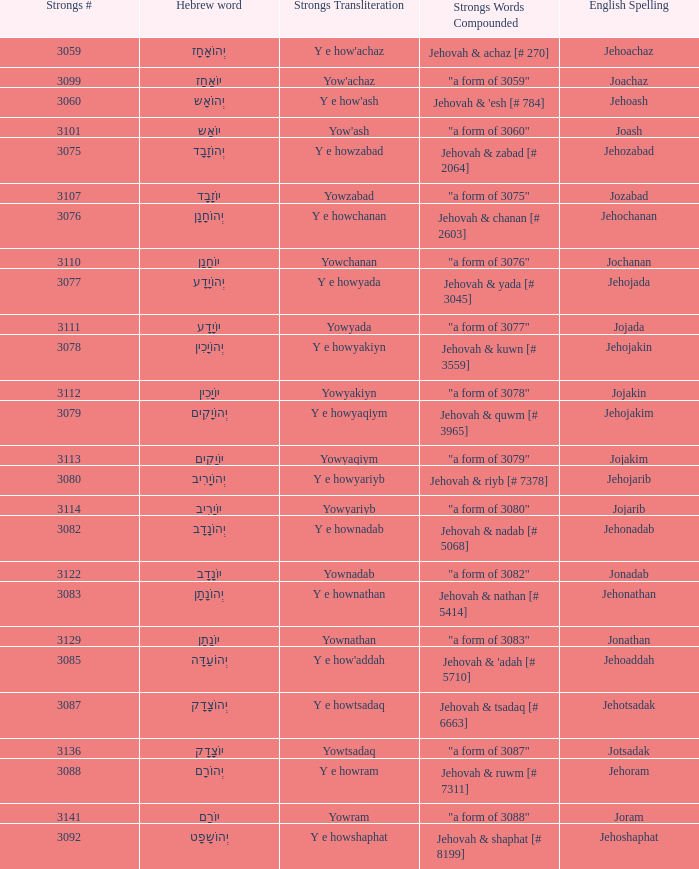What is the strongs words compounded when the english spelling is jonadab? "a form of 3082". 